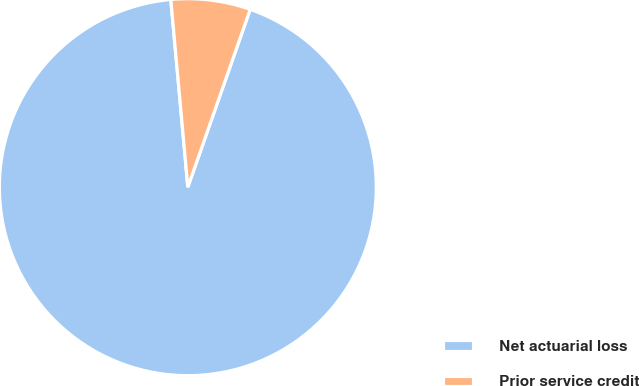<chart> <loc_0><loc_0><loc_500><loc_500><pie_chart><fcel>Net actuarial loss<fcel>Prior service credit<nl><fcel>93.19%<fcel>6.81%<nl></chart> 